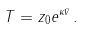<formula> <loc_0><loc_0><loc_500><loc_500>T = z _ { 0 } e ^ { \kappa \bar { v } } \, .</formula> 